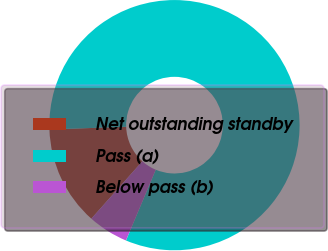Convert chart. <chart><loc_0><loc_0><loc_500><loc_500><pie_chart><fcel>Net outstanding standby<fcel>Pass (a)<fcel>Below pass (b)<nl><fcel>12.89%<fcel>81.88%<fcel>5.23%<nl></chart> 